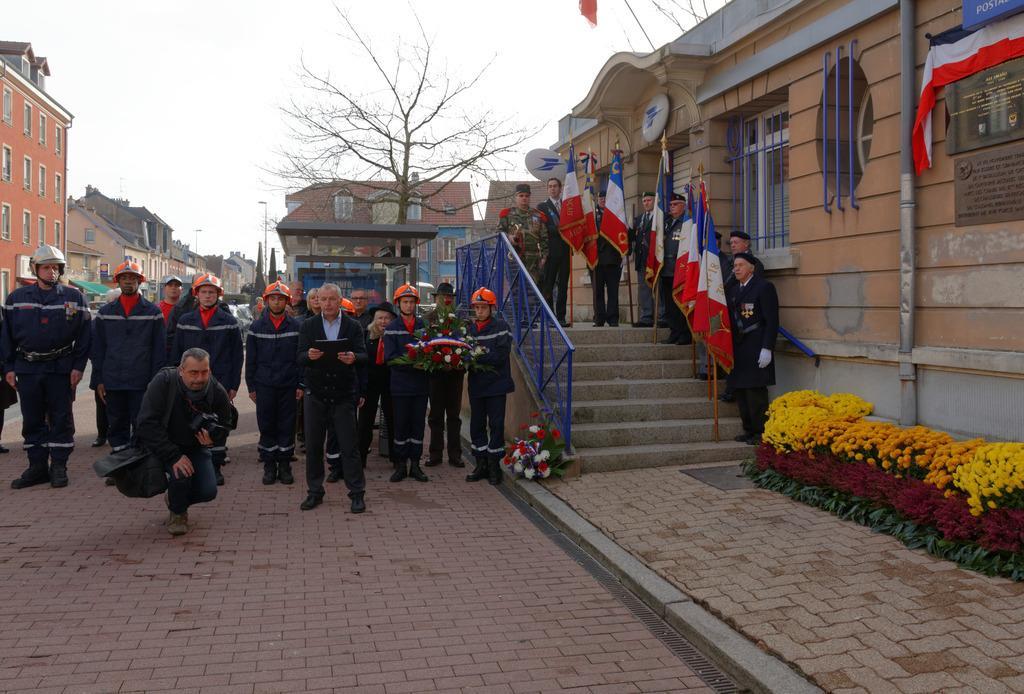Could you give a brief overview of what you see in this image? Here we can see people, bouquets, steps, flags and plants. To these plants there are flowers. Front this person wore bag and holding a camera. Background we can see buildings, bare tree, light pole and sky. To this building there are boards, pipe, windows and flag.  